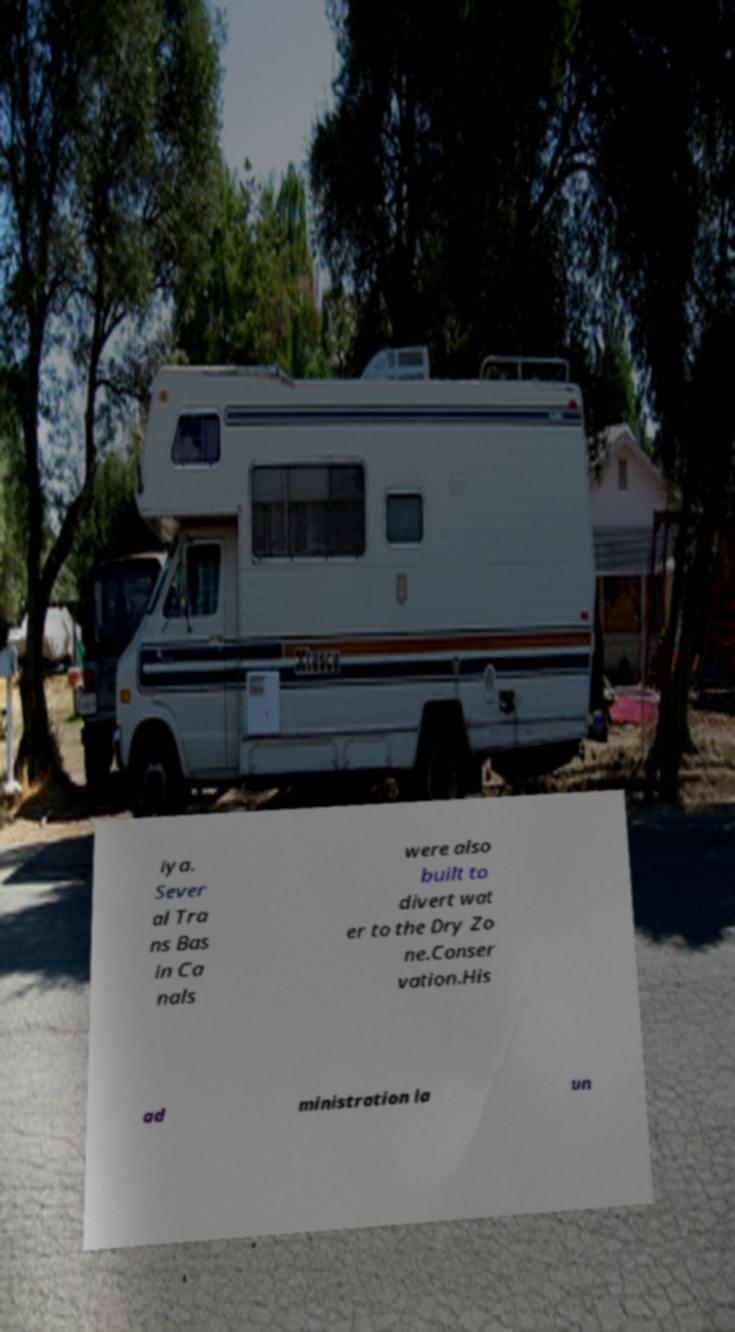Please read and relay the text visible in this image. What does it say? iya. Sever al Tra ns Bas in Ca nals were also built to divert wat er to the Dry Zo ne.Conser vation.His ad ministration la un 